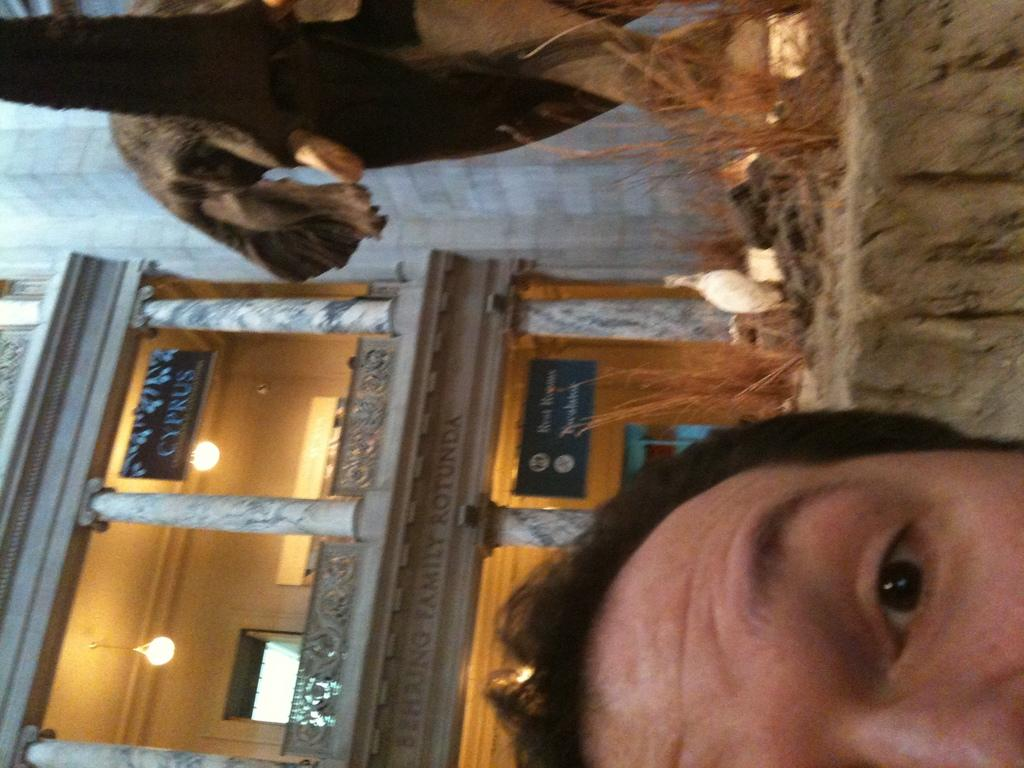Who or what is present in the image? There is a person in the image. What artistic object can be seen in the image? There is a sculpture in the image. What type of structure is visible in the image? There is a building in the image. What type of toys can be seen in the image? There are no toys present in the image. What level of harmony is depicted in the image? The image does not depict a level of harmony; it features a person, a sculpture, and a building. 